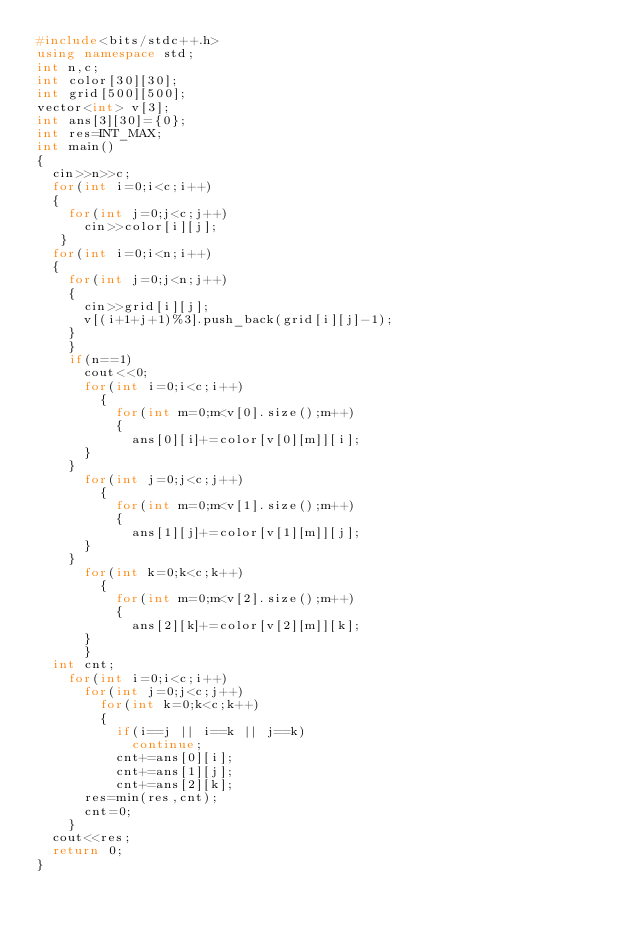<code> <loc_0><loc_0><loc_500><loc_500><_C++_>#include<bits/stdc++.h>
using namespace std;
int n,c;
int color[30][30];
int grid[500][500];
vector<int> v[3];
int ans[3][30]={0};
int res=INT_MAX;
int main()
{
	cin>>n>>c;
	for(int i=0;i<c;i++)
	{
		for(int j=0;j<c;j++)
		  cin>>color[i][j];
   }
	for(int i=0;i<n;i++)
	{
		for(int j=0;j<n;j++)
		{
			cin>>grid[i][j];
			v[(i+1+j+1)%3].push_back(grid[i][j]-1);
		}
    }
    if(n==1)
      cout<<0;
      for(int i=0;i<c;i++)
        {
        	for(int m=0;m<v[0].size();m++)
        	{
        		ans[0][i]+=color[v[0][m]][i];
			}
		}
      for(int j=0;j<c;j++)
        {
        	for(int m=0;m<v[1].size();m++)
        	{
        		ans[1][j]+=color[v[1][m]][j];
			}
		}
      for(int k=0;k<c;k++)
        {
        	for(int m=0;m<v[2].size();m++)
        	{
        		ans[2][k]+=color[v[2][m]][k];
			}
	    }
	int cnt;
    for(int i=0;i<c;i++)
      for(int j=0;j<c;j++)
        for(int k=0;k<c;k++)
        {
        	if(i==j || i==k || j==k)
        	  continue;
        	cnt+=ans[0][i];
        	cnt+=ans[1][j];
        	cnt+=ans[2][k];
			res=min(res,cnt);
			cnt=0;
		}
	cout<<res;
	return 0;
}</code> 